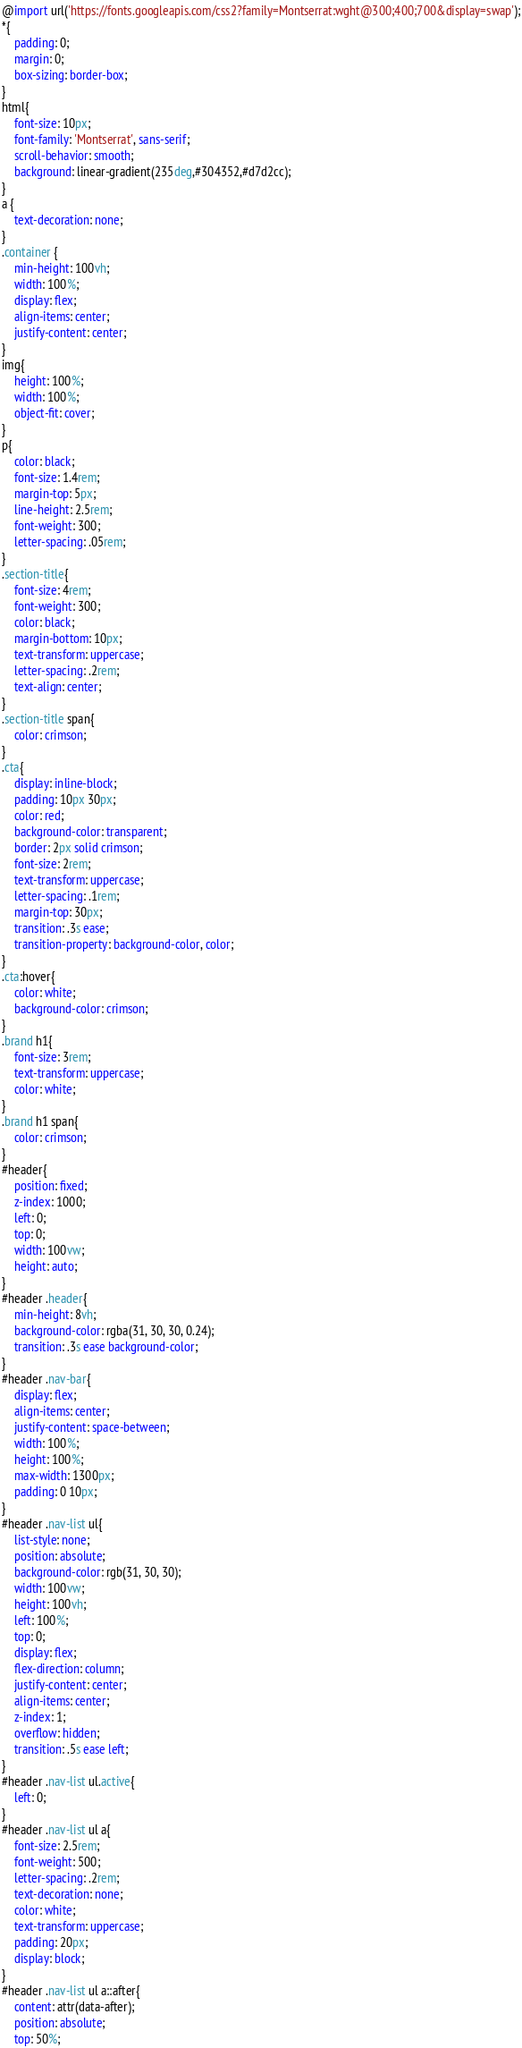<code> <loc_0><loc_0><loc_500><loc_500><_CSS_>@import url('https://fonts.googleapis.com/css2?family=Montserrat:wght@300;400;700&display=swap');
*{
    padding: 0;
    margin: 0;
    box-sizing: border-box;
}
html{
    font-size: 10px;
    font-family: 'Montserrat', sans-serif;
    scroll-behavior: smooth;
    background: linear-gradient(235deg,#304352,#d7d2cc);
}
a {
    text-decoration: none;
}
.container {
    min-height: 100vh;
    width: 100%;
    display: flex;
    align-items: center;
    justify-content: center;
}
img{
    height: 100%;
    width: 100%;
    object-fit: cover;
}
p{
    color: black;
    font-size: 1.4rem;
    margin-top: 5px;
    line-height: 2.5rem;
    font-weight: 300;
    letter-spacing: .05rem;
}
.section-title{
    font-size: 4rem;
    font-weight: 300;
    color: black;
    margin-bottom: 10px;
    text-transform: uppercase;
    letter-spacing: .2rem;
    text-align: center;
}
.section-title span{
    color: crimson;
}
.cta{
    display: inline-block;
    padding: 10px 30px;
    color: red;
    background-color: transparent;
    border: 2px solid crimson;
    font-size: 2rem;
    text-transform: uppercase;
    letter-spacing: .1rem;
    margin-top: 30px;
    transition: .3s ease;
    transition-property: background-color, color;
}
.cta:hover{
    color: white;
    background-color: crimson;
}
.brand h1{
    font-size: 3rem;
    text-transform: uppercase;
    color: white;
}
.brand h1 span{
    color: crimson;
}
#header{
    position: fixed;
    z-index: 1000;
    left: 0;
    top: 0;
    width: 100vw;
    height: auto;
}
#header .header{
    min-height: 8vh;
    background-color: rgba(31, 30, 30, 0.24);
    transition: .3s ease background-color;
}
#header .nav-bar{
    display: flex;
    align-items: center;
    justify-content: space-between;
    width: 100%;
    height: 100%;
    max-width: 1300px;
    padding: 0 10px;
}
#header .nav-list ul{
    list-style: none;
    position: absolute;
    background-color: rgb(31, 30, 30);
    width: 100vw;
    height: 100vh;
    left: 100%;
    top: 0;
    display: flex;
    flex-direction: column;
    justify-content: center;
    align-items: center;
    z-index: 1;
    overflow: hidden;
    transition: .5s ease left;
}
#header .nav-list ul.active{
    left: 0;
}
#header .nav-list ul a{
    font-size: 2.5rem;
    font-weight: 500;
    letter-spacing: .2rem;
    text-decoration: none;
    color: white;
    text-transform: uppercase;
    padding: 20px;
    display: block;
}
#header .nav-list ul a::after{
    content: attr(data-after);
    position: absolute;
    top: 50%;</code> 